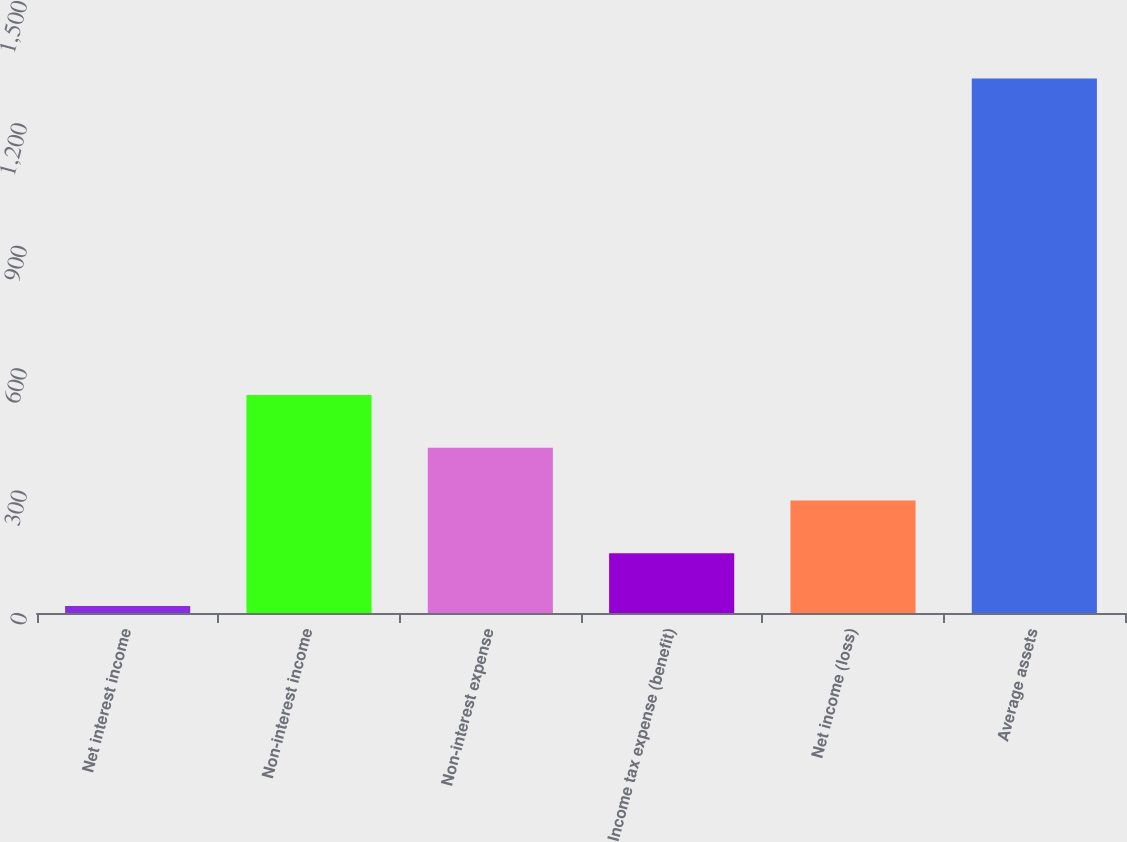Convert chart to OTSL. <chart><loc_0><loc_0><loc_500><loc_500><bar_chart><fcel>Net interest income<fcel>Non-interest income<fcel>Non-interest expense<fcel>Income tax expense (benefit)<fcel>Net income (loss)<fcel>Average assets<nl><fcel>17<fcel>534.2<fcel>404.9<fcel>146.3<fcel>275.6<fcel>1310<nl></chart> 